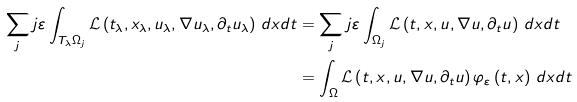<formula> <loc_0><loc_0><loc_500><loc_500>\sum _ { j } j \varepsilon \int _ { T _ { \lambda } \Omega _ { j } } \mathcal { L } \left ( t _ { \lambda } , x _ { \lambda } , u _ { \lambda } , \nabla u _ { \lambda } , \partial _ { t } u _ { \lambda } \right ) \, d x d t & = \sum _ { j } j \varepsilon \int _ { \Omega _ { j } } \mathcal { L } \left ( t , x , u , \nabla u , \partial _ { t } u \right ) \, d x d t \\ & = \int _ { \Omega } \mathcal { L } \left ( t , x , u , \nabla u , \partial _ { t } u \right ) \varphi _ { \varepsilon } \left ( t , x \right ) \, d x d t</formula> 